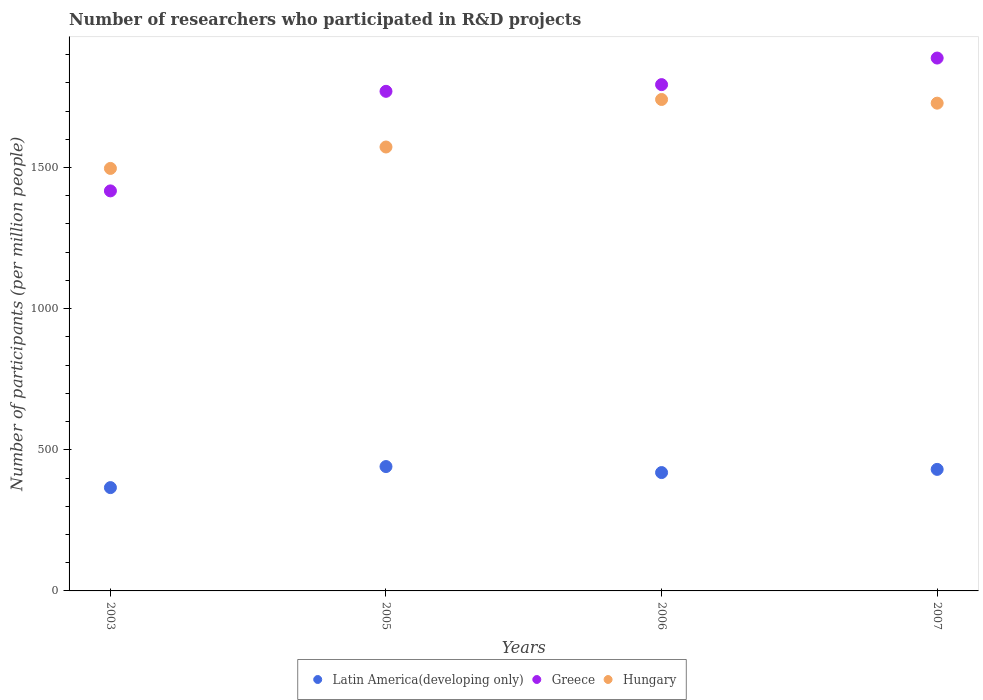How many different coloured dotlines are there?
Offer a terse response. 3. Is the number of dotlines equal to the number of legend labels?
Offer a terse response. Yes. What is the number of researchers who participated in R&D projects in Latin America(developing only) in 2003?
Offer a terse response. 366.02. Across all years, what is the maximum number of researchers who participated in R&D projects in Hungary?
Provide a short and direct response. 1741.04. Across all years, what is the minimum number of researchers who participated in R&D projects in Hungary?
Offer a very short reply. 1496.82. What is the total number of researchers who participated in R&D projects in Greece in the graph?
Your answer should be compact. 6868.7. What is the difference between the number of researchers who participated in R&D projects in Hungary in 2005 and that in 2007?
Your answer should be compact. -155.31. What is the difference between the number of researchers who participated in R&D projects in Latin America(developing only) in 2003 and the number of researchers who participated in R&D projects in Greece in 2005?
Keep it short and to the point. -1403.93. What is the average number of researchers who participated in R&D projects in Hungary per year?
Ensure brevity in your answer.  1634.65. In the year 2007, what is the difference between the number of researchers who participated in R&D projects in Latin America(developing only) and number of researchers who participated in R&D projects in Greece?
Make the answer very short. -1457.24. In how many years, is the number of researchers who participated in R&D projects in Greece greater than 600?
Your response must be concise. 4. What is the ratio of the number of researchers who participated in R&D projects in Hungary in 2005 to that in 2006?
Ensure brevity in your answer.  0.9. Is the difference between the number of researchers who participated in R&D projects in Latin America(developing only) in 2003 and 2006 greater than the difference between the number of researchers who participated in R&D projects in Greece in 2003 and 2006?
Your answer should be compact. Yes. What is the difference between the highest and the second highest number of researchers who participated in R&D projects in Latin America(developing only)?
Make the answer very short. 10.03. What is the difference between the highest and the lowest number of researchers who participated in R&D projects in Hungary?
Keep it short and to the point. 244.22. In how many years, is the number of researchers who participated in R&D projects in Greece greater than the average number of researchers who participated in R&D projects in Greece taken over all years?
Your answer should be very brief. 3. Is the sum of the number of researchers who participated in R&D projects in Hungary in 2003 and 2007 greater than the maximum number of researchers who participated in R&D projects in Greece across all years?
Make the answer very short. Yes. How many dotlines are there?
Provide a short and direct response. 3. How many years are there in the graph?
Offer a very short reply. 4. How many legend labels are there?
Provide a short and direct response. 3. What is the title of the graph?
Make the answer very short. Number of researchers who participated in R&D projects. What is the label or title of the X-axis?
Make the answer very short. Years. What is the label or title of the Y-axis?
Your response must be concise. Number of participants (per million people). What is the Number of participants (per million people) in Latin America(developing only) in 2003?
Your answer should be compact. 366.02. What is the Number of participants (per million people) of Greece in 2003?
Offer a terse response. 1417.21. What is the Number of participants (per million people) in Hungary in 2003?
Your answer should be very brief. 1496.82. What is the Number of participants (per million people) of Latin America(developing only) in 2005?
Offer a very short reply. 440.62. What is the Number of participants (per million people) in Greece in 2005?
Your answer should be very brief. 1769.95. What is the Number of participants (per million people) in Hungary in 2005?
Your answer should be compact. 1572.71. What is the Number of participants (per million people) of Latin America(developing only) in 2006?
Your answer should be compact. 419.31. What is the Number of participants (per million people) in Greece in 2006?
Offer a terse response. 1793.7. What is the Number of participants (per million people) of Hungary in 2006?
Provide a succinct answer. 1741.04. What is the Number of participants (per million people) of Latin America(developing only) in 2007?
Make the answer very short. 430.59. What is the Number of participants (per million people) of Greece in 2007?
Your answer should be compact. 1887.83. What is the Number of participants (per million people) in Hungary in 2007?
Give a very brief answer. 1728.02. Across all years, what is the maximum Number of participants (per million people) of Latin America(developing only)?
Make the answer very short. 440.62. Across all years, what is the maximum Number of participants (per million people) in Greece?
Make the answer very short. 1887.83. Across all years, what is the maximum Number of participants (per million people) of Hungary?
Make the answer very short. 1741.04. Across all years, what is the minimum Number of participants (per million people) of Latin America(developing only)?
Make the answer very short. 366.02. Across all years, what is the minimum Number of participants (per million people) of Greece?
Give a very brief answer. 1417.21. Across all years, what is the minimum Number of participants (per million people) in Hungary?
Provide a succinct answer. 1496.82. What is the total Number of participants (per million people) in Latin America(developing only) in the graph?
Offer a terse response. 1656.53. What is the total Number of participants (per million people) of Greece in the graph?
Give a very brief answer. 6868.7. What is the total Number of participants (per million people) of Hungary in the graph?
Provide a short and direct response. 6538.59. What is the difference between the Number of participants (per million people) of Latin America(developing only) in 2003 and that in 2005?
Your response must be concise. -74.59. What is the difference between the Number of participants (per million people) in Greece in 2003 and that in 2005?
Ensure brevity in your answer.  -352.74. What is the difference between the Number of participants (per million people) of Hungary in 2003 and that in 2005?
Offer a very short reply. -75.88. What is the difference between the Number of participants (per million people) of Latin America(developing only) in 2003 and that in 2006?
Offer a very short reply. -53.29. What is the difference between the Number of participants (per million people) of Greece in 2003 and that in 2006?
Your response must be concise. -376.49. What is the difference between the Number of participants (per million people) in Hungary in 2003 and that in 2006?
Ensure brevity in your answer.  -244.22. What is the difference between the Number of participants (per million people) of Latin America(developing only) in 2003 and that in 2007?
Give a very brief answer. -64.56. What is the difference between the Number of participants (per million people) in Greece in 2003 and that in 2007?
Give a very brief answer. -470.62. What is the difference between the Number of participants (per million people) of Hungary in 2003 and that in 2007?
Offer a very short reply. -231.19. What is the difference between the Number of participants (per million people) in Latin America(developing only) in 2005 and that in 2006?
Your answer should be compact. 21.31. What is the difference between the Number of participants (per million people) in Greece in 2005 and that in 2006?
Provide a short and direct response. -23.75. What is the difference between the Number of participants (per million people) in Hungary in 2005 and that in 2006?
Provide a succinct answer. -168.33. What is the difference between the Number of participants (per million people) in Latin America(developing only) in 2005 and that in 2007?
Make the answer very short. 10.03. What is the difference between the Number of participants (per million people) in Greece in 2005 and that in 2007?
Make the answer very short. -117.88. What is the difference between the Number of participants (per million people) of Hungary in 2005 and that in 2007?
Offer a terse response. -155.31. What is the difference between the Number of participants (per million people) in Latin America(developing only) in 2006 and that in 2007?
Keep it short and to the point. -11.28. What is the difference between the Number of participants (per million people) of Greece in 2006 and that in 2007?
Give a very brief answer. -94.13. What is the difference between the Number of participants (per million people) of Hungary in 2006 and that in 2007?
Your response must be concise. 13.02. What is the difference between the Number of participants (per million people) in Latin America(developing only) in 2003 and the Number of participants (per million people) in Greece in 2005?
Offer a terse response. -1403.93. What is the difference between the Number of participants (per million people) in Latin America(developing only) in 2003 and the Number of participants (per million people) in Hungary in 2005?
Offer a very short reply. -1206.69. What is the difference between the Number of participants (per million people) of Greece in 2003 and the Number of participants (per million people) of Hungary in 2005?
Keep it short and to the point. -155.5. What is the difference between the Number of participants (per million people) of Latin America(developing only) in 2003 and the Number of participants (per million people) of Greece in 2006?
Your answer should be compact. -1427.68. What is the difference between the Number of participants (per million people) of Latin America(developing only) in 2003 and the Number of participants (per million people) of Hungary in 2006?
Ensure brevity in your answer.  -1375.02. What is the difference between the Number of participants (per million people) of Greece in 2003 and the Number of participants (per million people) of Hungary in 2006?
Keep it short and to the point. -323.83. What is the difference between the Number of participants (per million people) in Latin America(developing only) in 2003 and the Number of participants (per million people) in Greece in 2007?
Make the answer very short. -1521.81. What is the difference between the Number of participants (per million people) of Latin America(developing only) in 2003 and the Number of participants (per million people) of Hungary in 2007?
Make the answer very short. -1361.99. What is the difference between the Number of participants (per million people) in Greece in 2003 and the Number of participants (per million people) in Hungary in 2007?
Provide a short and direct response. -310.81. What is the difference between the Number of participants (per million people) in Latin America(developing only) in 2005 and the Number of participants (per million people) in Greece in 2006?
Your answer should be compact. -1353.09. What is the difference between the Number of participants (per million people) in Latin America(developing only) in 2005 and the Number of participants (per million people) in Hungary in 2006?
Your answer should be compact. -1300.42. What is the difference between the Number of participants (per million people) of Greece in 2005 and the Number of participants (per million people) of Hungary in 2006?
Keep it short and to the point. 28.91. What is the difference between the Number of participants (per million people) of Latin America(developing only) in 2005 and the Number of participants (per million people) of Greece in 2007?
Provide a succinct answer. -1447.21. What is the difference between the Number of participants (per million people) of Latin America(developing only) in 2005 and the Number of participants (per million people) of Hungary in 2007?
Offer a terse response. -1287.4. What is the difference between the Number of participants (per million people) of Greece in 2005 and the Number of participants (per million people) of Hungary in 2007?
Your answer should be very brief. 41.94. What is the difference between the Number of participants (per million people) of Latin America(developing only) in 2006 and the Number of participants (per million people) of Greece in 2007?
Your answer should be very brief. -1468.52. What is the difference between the Number of participants (per million people) in Latin America(developing only) in 2006 and the Number of participants (per million people) in Hungary in 2007?
Keep it short and to the point. -1308.71. What is the difference between the Number of participants (per million people) of Greece in 2006 and the Number of participants (per million people) of Hungary in 2007?
Your answer should be very brief. 65.69. What is the average Number of participants (per million people) of Latin America(developing only) per year?
Provide a succinct answer. 414.13. What is the average Number of participants (per million people) of Greece per year?
Provide a short and direct response. 1717.17. What is the average Number of participants (per million people) of Hungary per year?
Your response must be concise. 1634.65. In the year 2003, what is the difference between the Number of participants (per million people) of Latin America(developing only) and Number of participants (per million people) of Greece?
Keep it short and to the point. -1051.19. In the year 2003, what is the difference between the Number of participants (per million people) of Latin America(developing only) and Number of participants (per million people) of Hungary?
Provide a short and direct response. -1130.8. In the year 2003, what is the difference between the Number of participants (per million people) of Greece and Number of participants (per million people) of Hungary?
Provide a short and direct response. -79.61. In the year 2005, what is the difference between the Number of participants (per million people) of Latin America(developing only) and Number of participants (per million people) of Greece?
Provide a succinct answer. -1329.34. In the year 2005, what is the difference between the Number of participants (per million people) of Latin America(developing only) and Number of participants (per million people) of Hungary?
Your response must be concise. -1132.09. In the year 2005, what is the difference between the Number of participants (per million people) in Greece and Number of participants (per million people) in Hungary?
Your response must be concise. 197.25. In the year 2006, what is the difference between the Number of participants (per million people) of Latin America(developing only) and Number of participants (per million people) of Greece?
Ensure brevity in your answer.  -1374.4. In the year 2006, what is the difference between the Number of participants (per million people) of Latin America(developing only) and Number of participants (per million people) of Hungary?
Give a very brief answer. -1321.73. In the year 2006, what is the difference between the Number of participants (per million people) of Greece and Number of participants (per million people) of Hungary?
Your response must be concise. 52.66. In the year 2007, what is the difference between the Number of participants (per million people) of Latin America(developing only) and Number of participants (per million people) of Greece?
Ensure brevity in your answer.  -1457.24. In the year 2007, what is the difference between the Number of participants (per million people) of Latin America(developing only) and Number of participants (per million people) of Hungary?
Your answer should be compact. -1297.43. In the year 2007, what is the difference between the Number of participants (per million people) of Greece and Number of participants (per million people) of Hungary?
Give a very brief answer. 159.81. What is the ratio of the Number of participants (per million people) in Latin America(developing only) in 2003 to that in 2005?
Your answer should be compact. 0.83. What is the ratio of the Number of participants (per million people) in Greece in 2003 to that in 2005?
Make the answer very short. 0.8. What is the ratio of the Number of participants (per million people) in Hungary in 2003 to that in 2005?
Your answer should be very brief. 0.95. What is the ratio of the Number of participants (per million people) of Latin America(developing only) in 2003 to that in 2006?
Your response must be concise. 0.87. What is the ratio of the Number of participants (per million people) in Greece in 2003 to that in 2006?
Provide a short and direct response. 0.79. What is the ratio of the Number of participants (per million people) of Hungary in 2003 to that in 2006?
Your response must be concise. 0.86. What is the ratio of the Number of participants (per million people) in Latin America(developing only) in 2003 to that in 2007?
Keep it short and to the point. 0.85. What is the ratio of the Number of participants (per million people) in Greece in 2003 to that in 2007?
Your response must be concise. 0.75. What is the ratio of the Number of participants (per million people) in Hungary in 2003 to that in 2007?
Provide a short and direct response. 0.87. What is the ratio of the Number of participants (per million people) in Latin America(developing only) in 2005 to that in 2006?
Make the answer very short. 1.05. What is the ratio of the Number of participants (per million people) in Hungary in 2005 to that in 2006?
Offer a terse response. 0.9. What is the ratio of the Number of participants (per million people) in Latin America(developing only) in 2005 to that in 2007?
Ensure brevity in your answer.  1.02. What is the ratio of the Number of participants (per million people) in Greece in 2005 to that in 2007?
Offer a very short reply. 0.94. What is the ratio of the Number of participants (per million people) in Hungary in 2005 to that in 2007?
Offer a terse response. 0.91. What is the ratio of the Number of participants (per million people) in Latin America(developing only) in 2006 to that in 2007?
Make the answer very short. 0.97. What is the ratio of the Number of participants (per million people) of Greece in 2006 to that in 2007?
Give a very brief answer. 0.95. What is the ratio of the Number of participants (per million people) in Hungary in 2006 to that in 2007?
Provide a short and direct response. 1.01. What is the difference between the highest and the second highest Number of participants (per million people) of Latin America(developing only)?
Your answer should be compact. 10.03. What is the difference between the highest and the second highest Number of participants (per million people) in Greece?
Provide a succinct answer. 94.13. What is the difference between the highest and the second highest Number of participants (per million people) of Hungary?
Give a very brief answer. 13.02. What is the difference between the highest and the lowest Number of participants (per million people) in Latin America(developing only)?
Keep it short and to the point. 74.59. What is the difference between the highest and the lowest Number of participants (per million people) in Greece?
Provide a short and direct response. 470.62. What is the difference between the highest and the lowest Number of participants (per million people) of Hungary?
Provide a short and direct response. 244.22. 